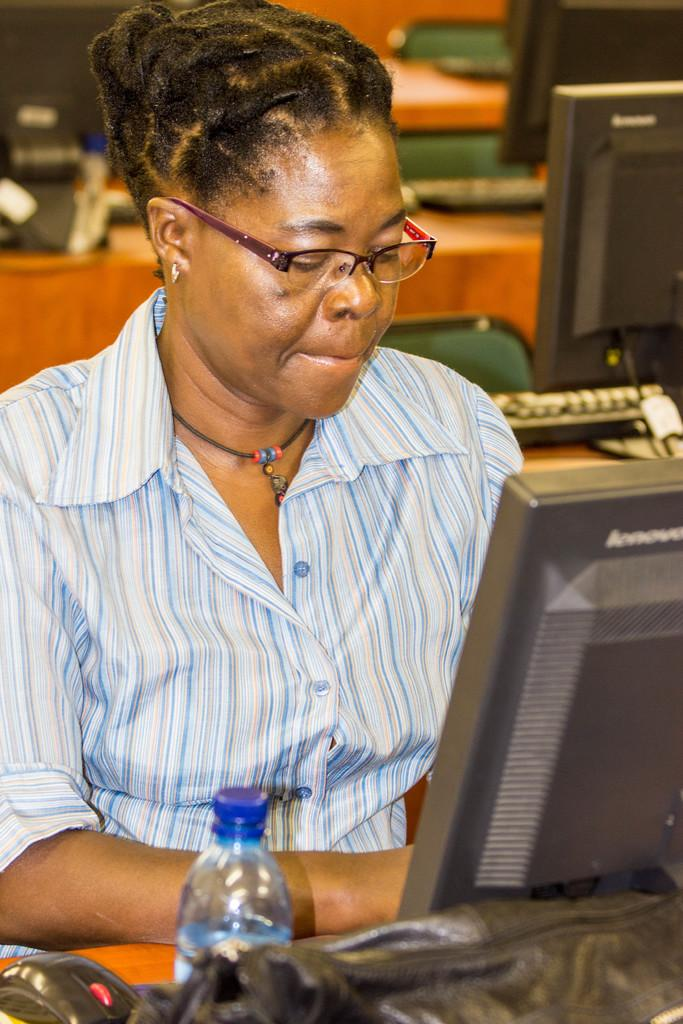Who is the main subject in the image? There is a woman in the image. What is the woman doing in the image? The woman is in front of a system. What can be seen on the table in the image? There is a bottle of water on a table in the image. What type of environment is depicted in the image? There are systems with chairs and tables present in the image, suggesting a work or study environment. What type of vegetable is the woman holding in the image? There is no vegetable present in the image; the woman is in front of a system and there is a bottle of water on a table. 